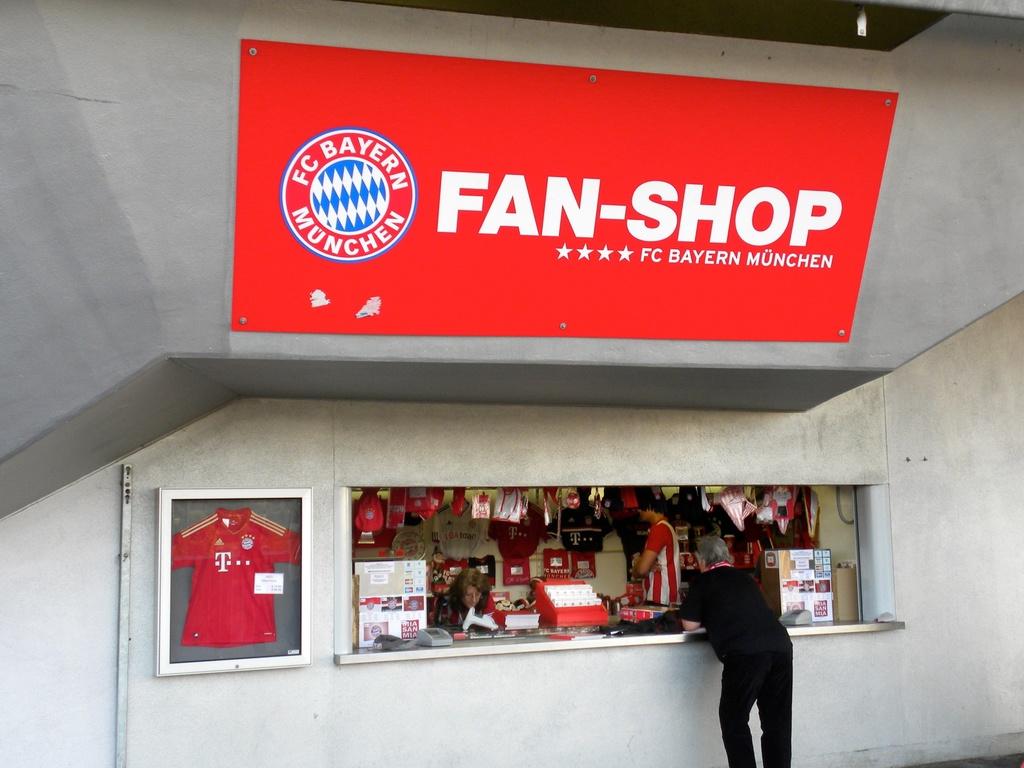What is the name of the shop?
Your answer should be very brief. Fan-shop. 